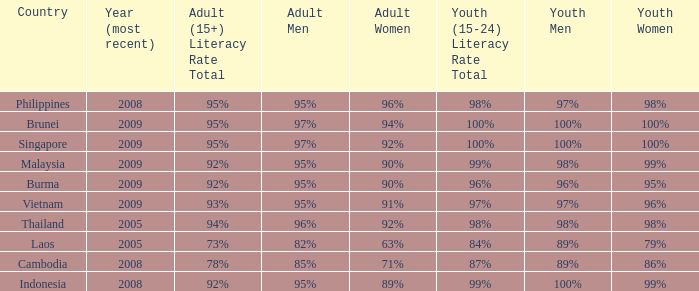Which country has its most recent year as being 2005 and has an Adult Men literacy rate of 96%? Thailand. 